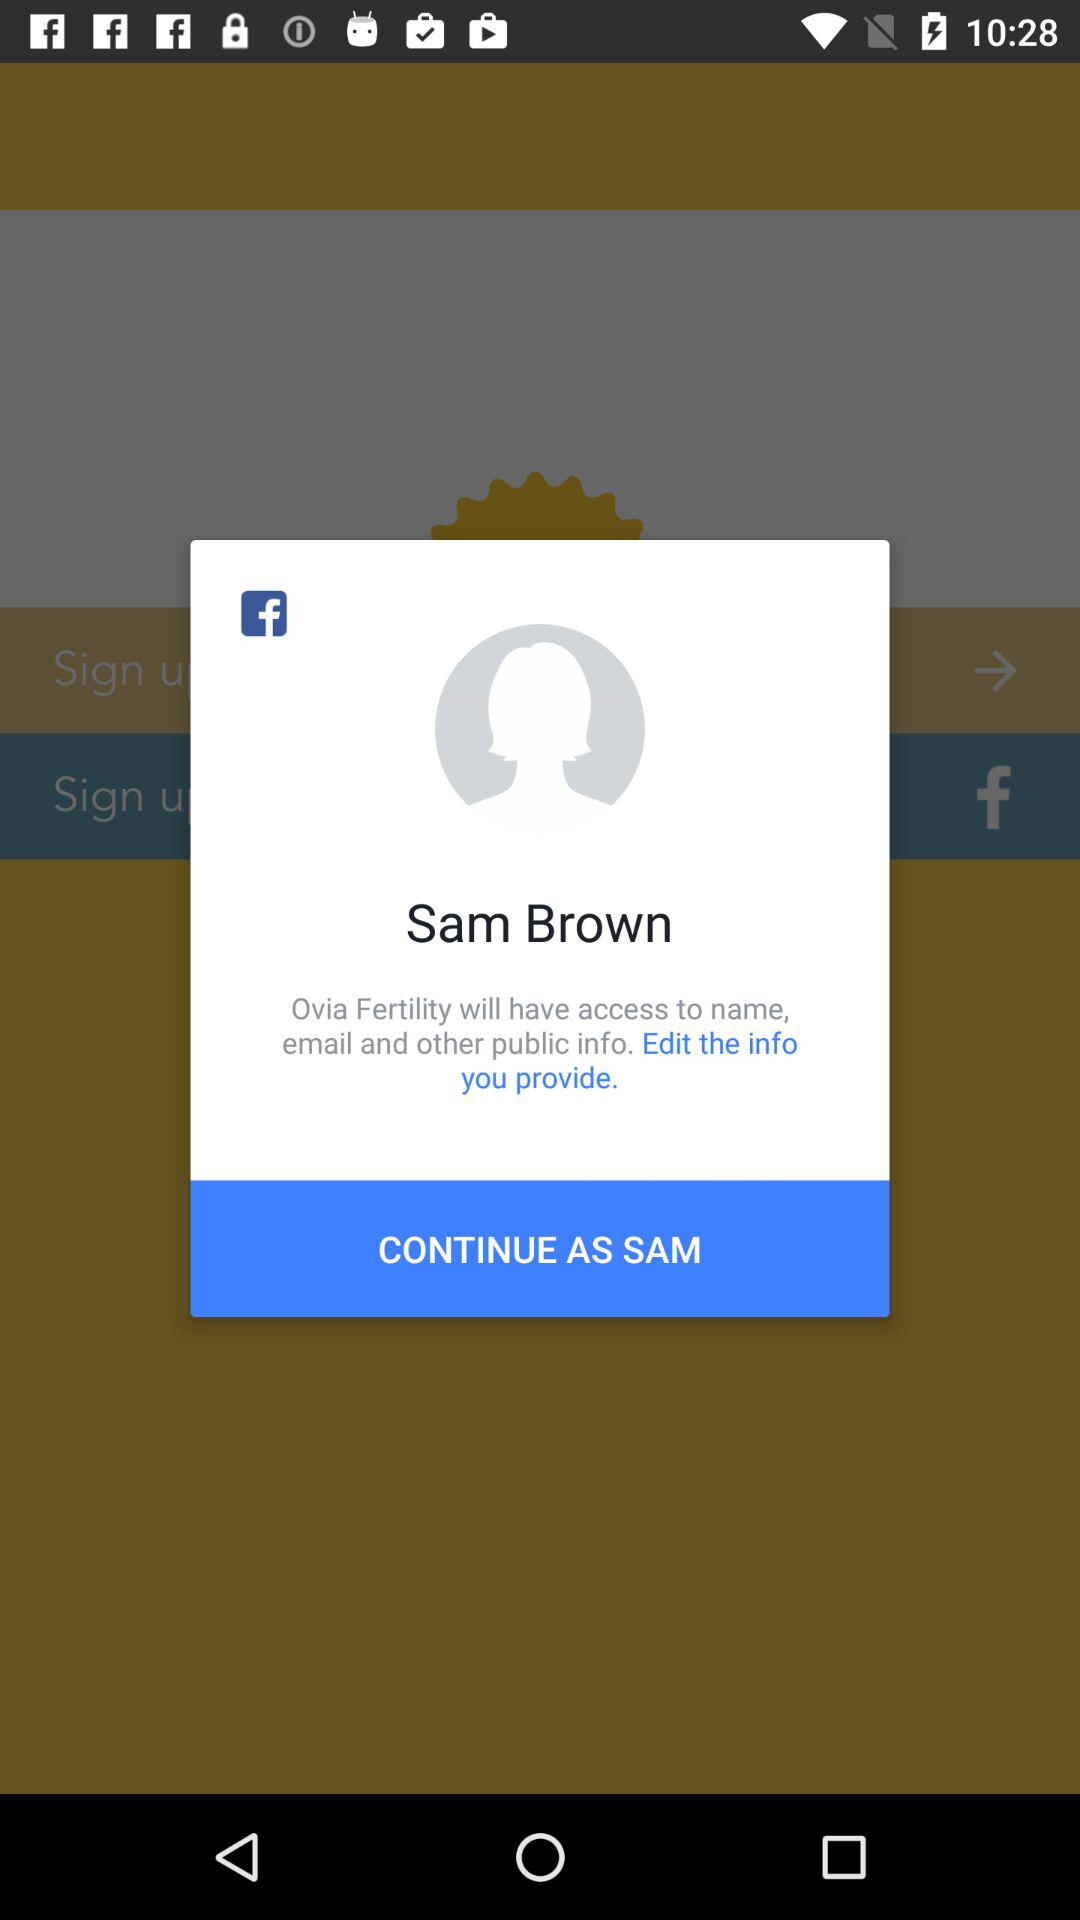What application is asking for permission? The application name is Ovia Fertility. 